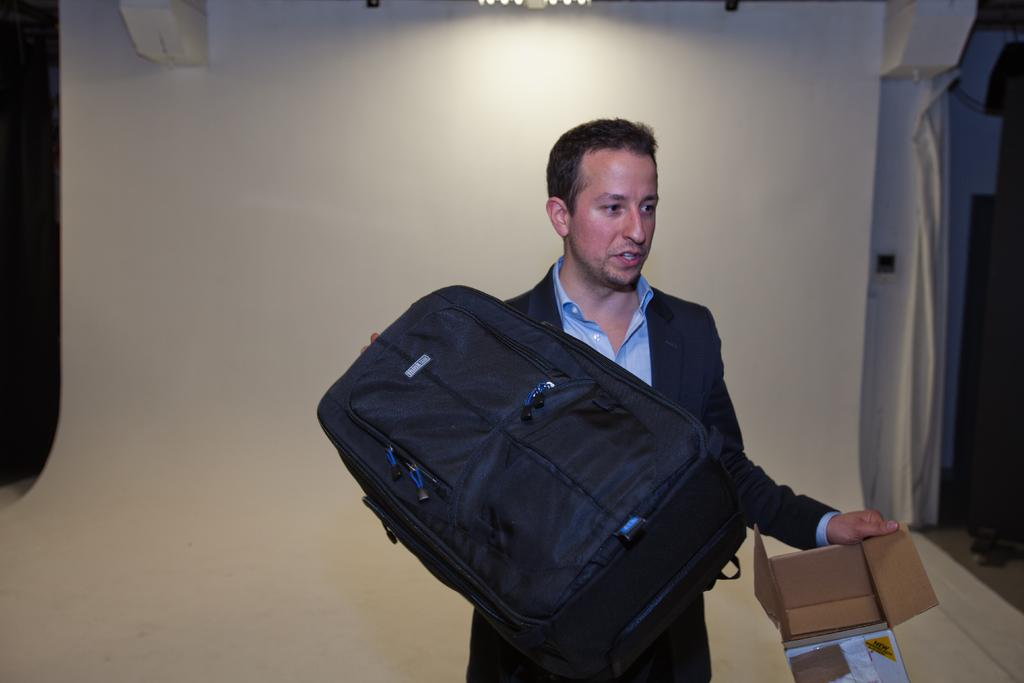Who is present in the image? There is a man in the image. What is the man holding in the image? The man is holding a bag and a box. What can be seen in the background of the image? There is a wall in the background of the image. What type of pet is the man walking in the image? There is no pet present in the image, and the man is not walking. 